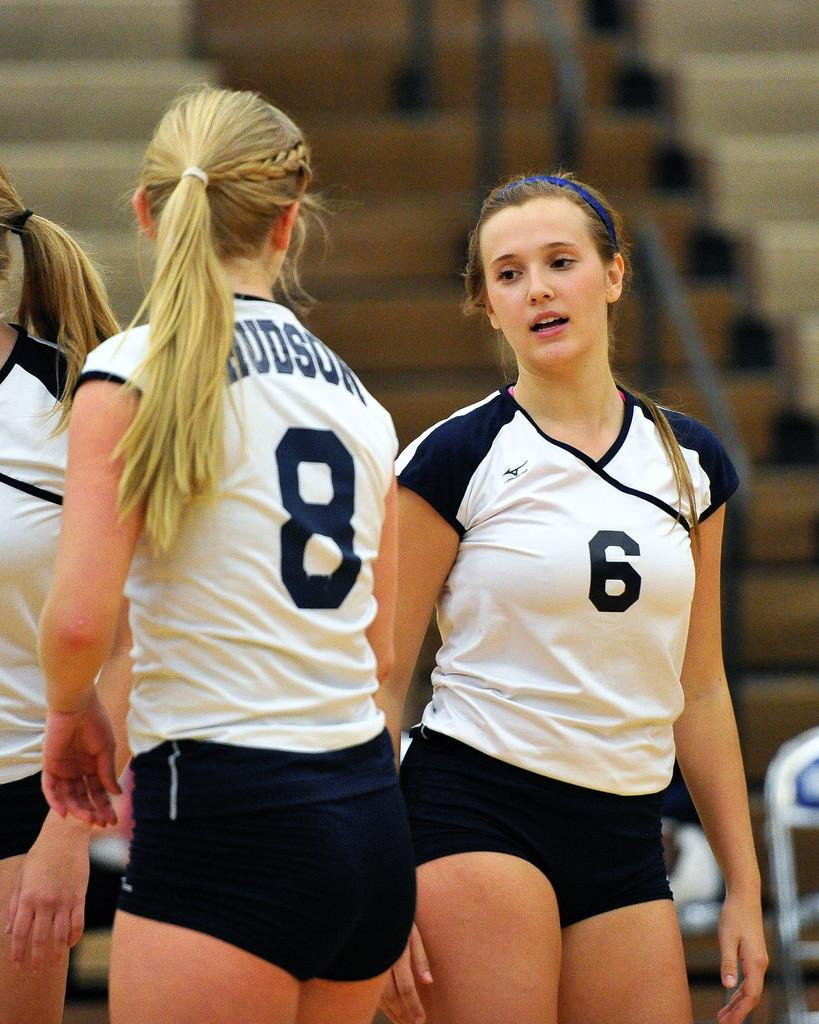<image>
Describe the image concisely. the number 6 is on the girl's jersey 